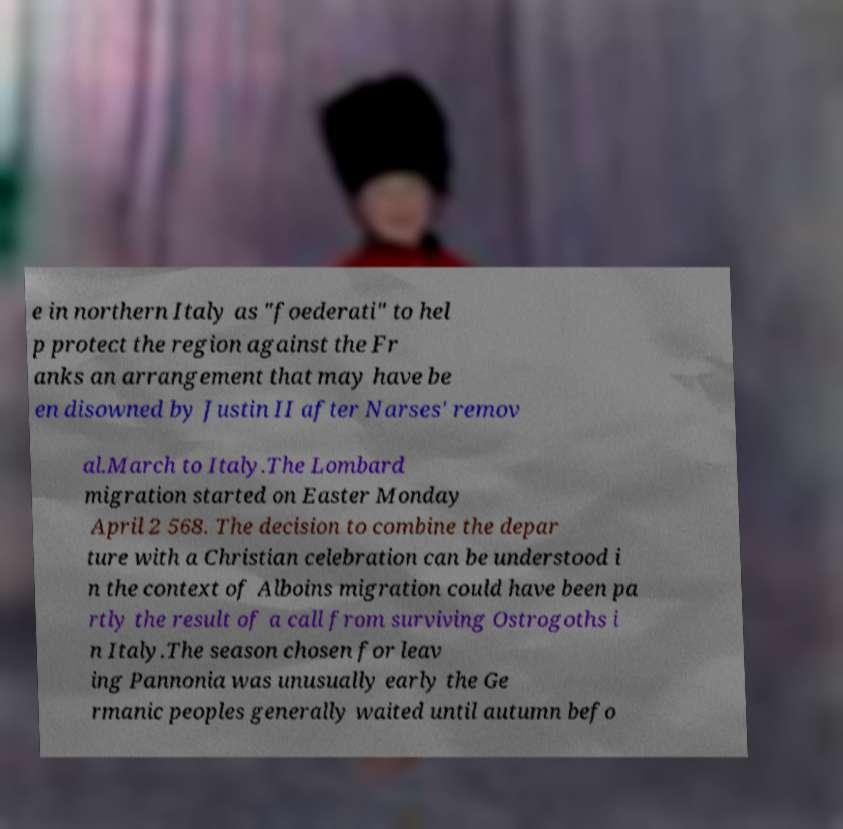Could you assist in decoding the text presented in this image and type it out clearly? e in northern Italy as "foederati" to hel p protect the region against the Fr anks an arrangement that may have be en disowned by Justin II after Narses' remov al.March to Italy.The Lombard migration started on Easter Monday April 2 568. The decision to combine the depar ture with a Christian celebration can be understood i n the context of Alboins migration could have been pa rtly the result of a call from surviving Ostrogoths i n Italy.The season chosen for leav ing Pannonia was unusually early the Ge rmanic peoples generally waited until autumn befo 